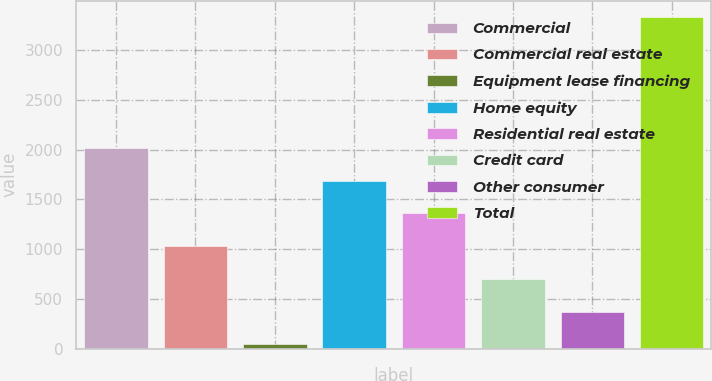Convert chart. <chart><loc_0><loc_0><loc_500><loc_500><bar_chart><fcel>Commercial<fcel>Commercial real estate<fcel>Equipment lease financing<fcel>Home equity<fcel>Residential real estate<fcel>Credit card<fcel>Other consumer<fcel>Total<nl><fcel>2016.2<fcel>1030.1<fcel>44<fcel>1687.5<fcel>1358.8<fcel>701.4<fcel>372.7<fcel>3331<nl></chart> 